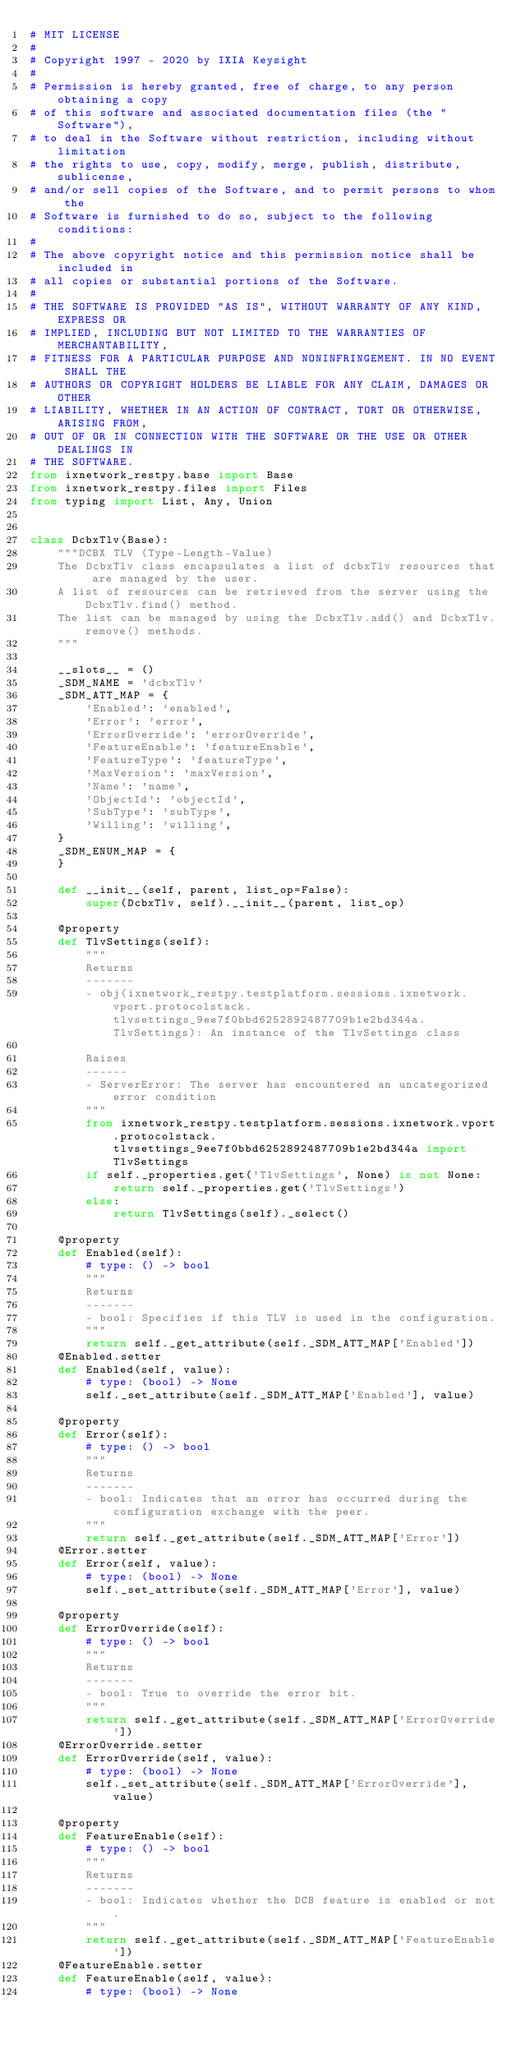<code> <loc_0><loc_0><loc_500><loc_500><_Python_># MIT LICENSE
#
# Copyright 1997 - 2020 by IXIA Keysight
#
# Permission is hereby granted, free of charge, to any person obtaining a copy
# of this software and associated documentation files (the "Software"),
# to deal in the Software without restriction, including without limitation
# the rights to use, copy, modify, merge, publish, distribute, sublicense,
# and/or sell copies of the Software, and to permit persons to whom the
# Software is furnished to do so, subject to the following conditions:
#
# The above copyright notice and this permission notice shall be included in
# all copies or substantial portions of the Software.
#
# THE SOFTWARE IS PROVIDED "AS IS", WITHOUT WARRANTY OF ANY KIND, EXPRESS OR
# IMPLIED, INCLUDING BUT NOT LIMITED TO THE WARRANTIES OF MERCHANTABILITY,
# FITNESS FOR A PARTICULAR PURPOSE AND NONINFRINGEMENT. IN NO EVENT SHALL THE
# AUTHORS OR COPYRIGHT HOLDERS BE LIABLE FOR ANY CLAIM, DAMAGES OR OTHER
# LIABILITY, WHETHER IN AN ACTION OF CONTRACT, TORT OR OTHERWISE, ARISING FROM,
# OUT OF OR IN CONNECTION WITH THE SOFTWARE OR THE USE OR OTHER DEALINGS IN
# THE SOFTWARE. 
from ixnetwork_restpy.base import Base
from ixnetwork_restpy.files import Files
from typing import List, Any, Union


class DcbxTlv(Base):
    """DCBX TLV (Type-Length-Value)
    The DcbxTlv class encapsulates a list of dcbxTlv resources that are managed by the user.
    A list of resources can be retrieved from the server using the DcbxTlv.find() method.
    The list can be managed by using the DcbxTlv.add() and DcbxTlv.remove() methods.
    """

    __slots__ = ()
    _SDM_NAME = 'dcbxTlv'
    _SDM_ATT_MAP = {
        'Enabled': 'enabled',
        'Error': 'error',
        'ErrorOverride': 'errorOverride',
        'FeatureEnable': 'featureEnable',
        'FeatureType': 'featureType',
        'MaxVersion': 'maxVersion',
        'Name': 'name',
        'ObjectId': 'objectId',
        'SubType': 'subType',
        'Willing': 'willing',
    }
    _SDM_ENUM_MAP = {
    }

    def __init__(self, parent, list_op=False):
        super(DcbxTlv, self).__init__(parent, list_op)

    @property
    def TlvSettings(self):
        """
        Returns
        -------
        - obj(ixnetwork_restpy.testplatform.sessions.ixnetwork.vport.protocolstack.tlvsettings_9ee7f0bbd6252892487709b1e2bd344a.TlvSettings): An instance of the TlvSettings class

        Raises
        ------
        - ServerError: The server has encountered an uncategorized error condition
        """
        from ixnetwork_restpy.testplatform.sessions.ixnetwork.vport.protocolstack.tlvsettings_9ee7f0bbd6252892487709b1e2bd344a import TlvSettings
        if self._properties.get('TlvSettings', None) is not None:
            return self._properties.get('TlvSettings')
        else:
            return TlvSettings(self)._select()

    @property
    def Enabled(self):
        # type: () -> bool
        """
        Returns
        -------
        - bool: Specifies if this TLV is used in the configuration.
        """
        return self._get_attribute(self._SDM_ATT_MAP['Enabled'])
    @Enabled.setter
    def Enabled(self, value):
        # type: (bool) -> None
        self._set_attribute(self._SDM_ATT_MAP['Enabled'], value)

    @property
    def Error(self):
        # type: () -> bool
        """
        Returns
        -------
        - bool: Indicates that an error has occurred during the configuration exchange with the peer.
        """
        return self._get_attribute(self._SDM_ATT_MAP['Error'])
    @Error.setter
    def Error(self, value):
        # type: (bool) -> None
        self._set_attribute(self._SDM_ATT_MAP['Error'], value)

    @property
    def ErrorOverride(self):
        # type: () -> bool
        """
        Returns
        -------
        - bool: True to override the error bit.
        """
        return self._get_attribute(self._SDM_ATT_MAP['ErrorOverride'])
    @ErrorOverride.setter
    def ErrorOverride(self, value):
        # type: (bool) -> None
        self._set_attribute(self._SDM_ATT_MAP['ErrorOverride'], value)

    @property
    def FeatureEnable(self):
        # type: () -> bool
        """
        Returns
        -------
        - bool: Indicates whether the DCB feature is enabled or not.
        """
        return self._get_attribute(self._SDM_ATT_MAP['FeatureEnable'])
    @FeatureEnable.setter
    def FeatureEnable(self, value):
        # type: (bool) -> None</code> 